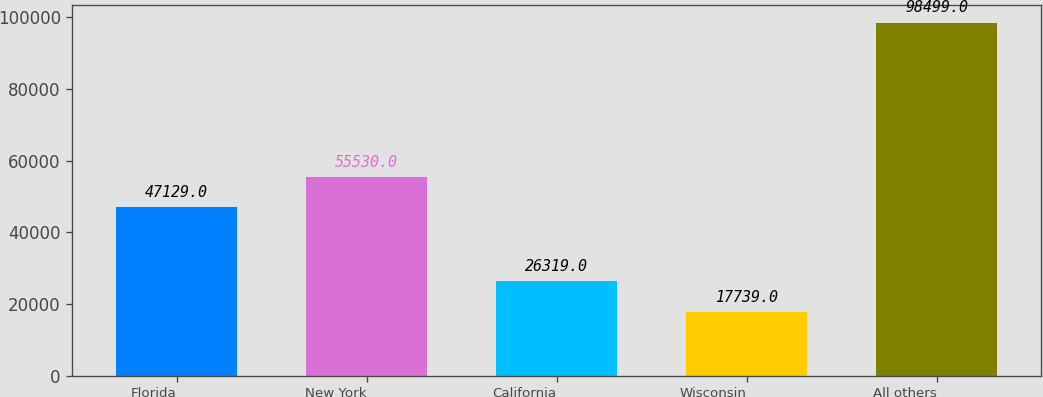Convert chart to OTSL. <chart><loc_0><loc_0><loc_500><loc_500><bar_chart><fcel>Florida<fcel>New York<fcel>California<fcel>Wisconsin<fcel>All others<nl><fcel>47129<fcel>55530<fcel>26319<fcel>17739<fcel>98499<nl></chart> 